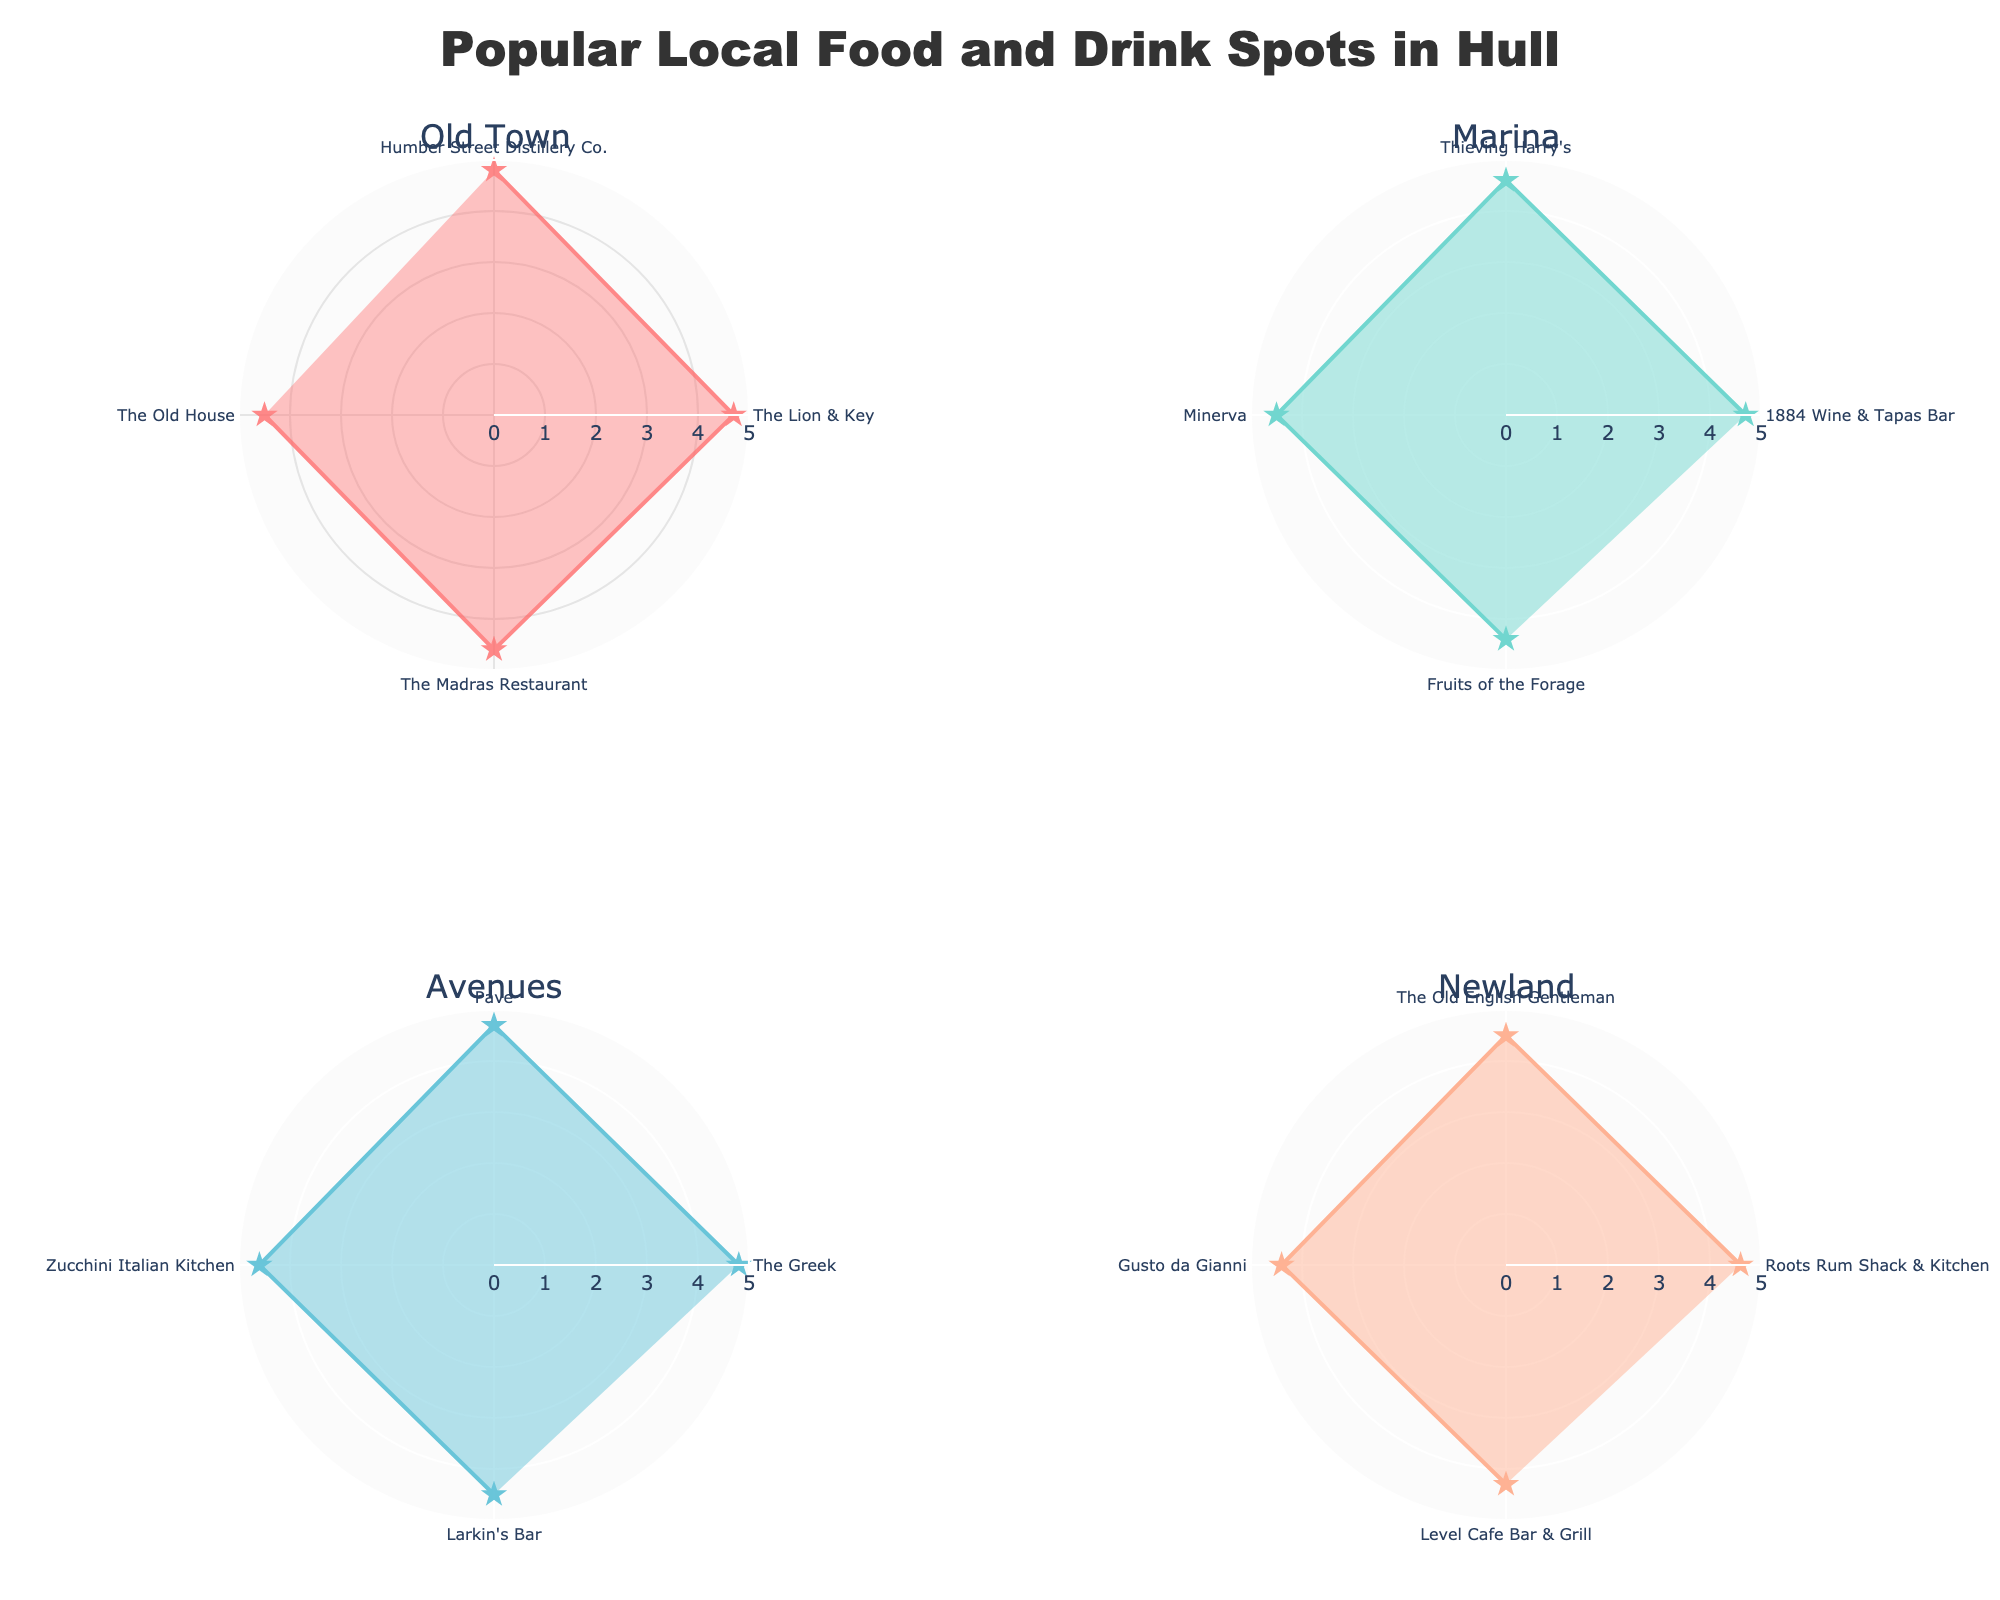What is the highest-rated spot in the Old Town? To find the highest-rated spot in the Old Town, look at the Old Town subplot and identify the maximum value on the radial axis. The spot with the highest radial line reaching 4.8 is "Humber Street Distillery Co."
Answer: Humber Street Distillery Co How many spots are there in the Marina neighborhood? Count the data points (or lines) within the Marina subplot. There are four lines, indicating there are four spots.
Answer: 4 Which neighborhood has the spot with the lowest rating, and what spot is it? Review all subplots to find the spot with the lowest radial axis value. This occurs in the Newland subplot, with "Level Cafe Bar & Grill" rated 4.3.
Answer: Newland, Level Cafe Bar & Grill What is the average rating of the spots in the Avenues neighborhood? Sum the ratings of all spots in the Avenues subplot: 4.8, 4.7, 4.6, 4.5. The sum is 18.6. There are 4 spots, so average = 18.6 / 4.
Answer: 4.65 Is the average rating higher in Old Town or Marina? Calculate the average rating for both neighborhoods. Old Town: (4.8 + 4.7 + 4.6 + 4.5) / 4 = 4.65. Marina: (4.7 + 4.6 + 4.5 + 4.4) / 4 = 4.55. Compare 4.65 and 4.55.
Answer: Old Town Which three spots have the highest ratings across all neighborhoods? Identify the highest radial lines in all subplots. "Humber Street Distillery Co." (Old Town), "The Greek" (Avenues), and "Pave" (Avenues) each have a rating of 4.8.
Answer: Humber Street Distillery Co., The Greek, Pave What types of establishments are found in the Marina neighborhood? Look at the labels in the Marina subplot. The types are Tapas Bar, Cafe, Pub, and Cafe.
Answer: Tapas Bar, Cafe, Pub, Cafe Which neighborhood has the most variety in types of food and drink spots? Note the different types in each subplot. Old Town: Bar, Pub, Indian Restaurant, Restaurant & Bar. Marina: Tapas Bar, Cafe, Pub. Avenues: Diner, Bar, Italian Restaurant, Pub. Newland: Caribbean Restaurant, Pub, Italian Restaurant, Cafe. Old Town and Avenues both have four unique types.
Answer: Old Town and Avenues What is the range of ratings for spots in the Newland neighborhood? Identify the highest and lowest ratings in the Newland subplot: The highest is 4.6, and the lowest is 4.3. Calculate the difference: 4.6 - 4.3.
Answer: 0.3 